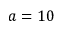Convert formula to latex. <formula><loc_0><loc_0><loc_500><loc_500>a = 1 0</formula> 